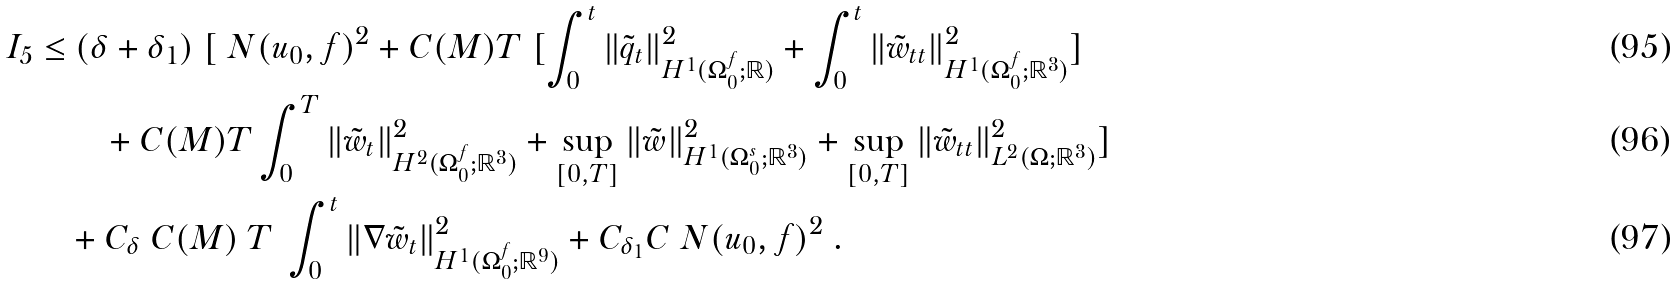Convert formula to latex. <formula><loc_0><loc_0><loc_500><loc_500>I _ { 5 } \leq & \ ( \delta + \delta _ { 1 } ) \ [ \ N ( u _ { 0 } , f ) ^ { 2 } + C ( M ) T \ [ \int _ { 0 } ^ { t } \| \tilde { q } _ { t } \| ^ { 2 } _ { H ^ { 1 } ( \Omega _ { 0 } ^ { f } ; { \mathbb { R } } ) } + \int _ { 0 } ^ { t } \| \tilde { w } _ { t t } \| ^ { 2 } _ { H ^ { 1 } ( \Omega _ { 0 } ^ { f } ; { \mathbb { R } } ^ { 3 } ) } ] \\ & \quad + C ( M ) T \int _ { 0 } ^ { T } \| \tilde { w } _ { t } \| ^ { 2 } _ { H ^ { 2 } ( \Omega _ { 0 } ^ { f } ; { \mathbb { R } } ^ { 3 } ) } + \sup _ { [ 0 , T ] } \| \tilde { w } \| ^ { 2 } _ { H ^ { 1 } ( \Omega _ { 0 } ^ { s } ; { \mathbb { R } } ^ { 3 } ) } + \sup _ { [ 0 , T ] } \| \tilde { w } _ { t t } \| ^ { 2 } _ { L ^ { 2 } ( \Omega ; { \mathbb { R } } ^ { 3 } ) } ] \\ & + C _ { \delta } \ C ( M ) \ T \ \int _ { 0 } ^ { t } \| \nabla \tilde { w } _ { t } \| ^ { 2 } _ { H ^ { 1 } ( \Omega _ { 0 } ^ { f } ; { \mathbb { R } } ^ { 9 } ) } + C _ { \delta _ { 1 } } C \ N ( u _ { 0 } , f ) ^ { 2 } \ .</formula> 